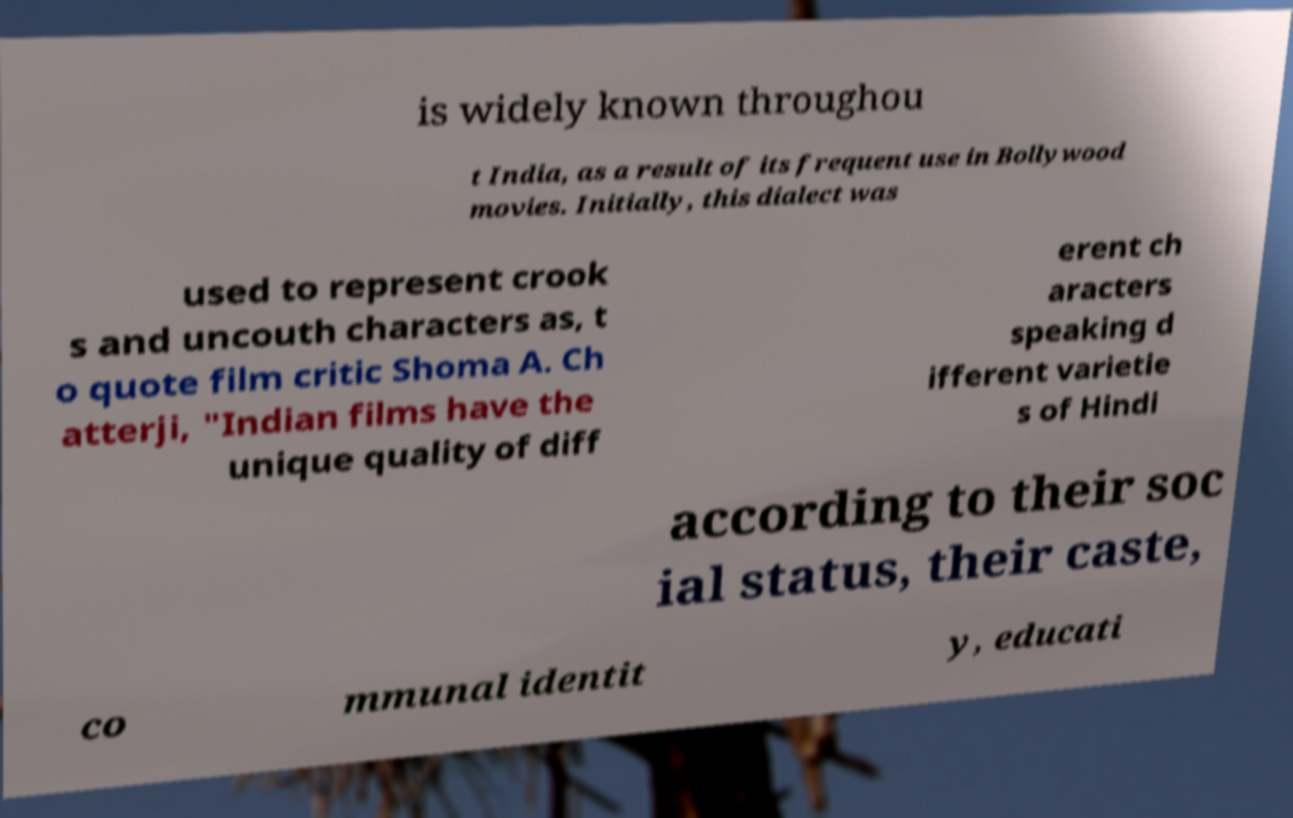Can you read and provide the text displayed in the image?This photo seems to have some interesting text. Can you extract and type it out for me? is widely known throughou t India, as a result of its frequent use in Bollywood movies. Initially, this dialect was used to represent crook s and uncouth characters as, t o quote film critic Shoma A. Ch atterji, "Indian films have the unique quality of diff erent ch aracters speaking d ifferent varietie s of Hindi according to their soc ial status, their caste, co mmunal identit y, educati 